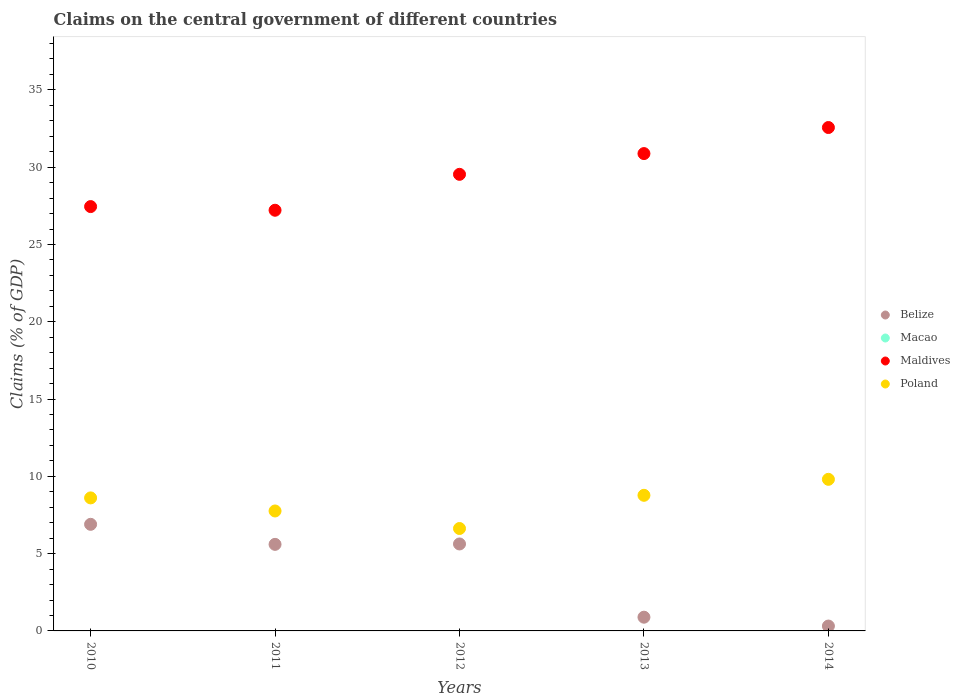How many different coloured dotlines are there?
Give a very brief answer. 3. Is the number of dotlines equal to the number of legend labels?
Keep it short and to the point. No. What is the percentage of GDP claimed on the central government in Belize in 2011?
Keep it short and to the point. 5.6. Across all years, what is the maximum percentage of GDP claimed on the central government in Maldives?
Offer a very short reply. 32.57. Across all years, what is the minimum percentage of GDP claimed on the central government in Poland?
Give a very brief answer. 6.63. What is the total percentage of GDP claimed on the central government in Poland in the graph?
Make the answer very short. 41.57. What is the difference between the percentage of GDP claimed on the central government in Belize in 2012 and that in 2014?
Offer a very short reply. 5.31. What is the difference between the percentage of GDP claimed on the central government in Belize in 2013 and the percentage of GDP claimed on the central government in Macao in 2014?
Your answer should be compact. 0.89. What is the average percentage of GDP claimed on the central government in Maldives per year?
Offer a very short reply. 29.53. In the year 2011, what is the difference between the percentage of GDP claimed on the central government in Belize and percentage of GDP claimed on the central government in Poland?
Make the answer very short. -2.16. In how many years, is the percentage of GDP claimed on the central government in Maldives greater than 5 %?
Your answer should be compact. 5. What is the ratio of the percentage of GDP claimed on the central government in Poland in 2013 to that in 2014?
Give a very brief answer. 0.89. Is the percentage of GDP claimed on the central government in Maldives in 2010 less than that in 2013?
Offer a terse response. Yes. What is the difference between the highest and the second highest percentage of GDP claimed on the central government in Maldives?
Keep it short and to the point. 1.69. What is the difference between the highest and the lowest percentage of GDP claimed on the central government in Belize?
Ensure brevity in your answer.  6.58. Is the sum of the percentage of GDP claimed on the central government in Poland in 2011 and 2014 greater than the maximum percentage of GDP claimed on the central government in Maldives across all years?
Ensure brevity in your answer.  No. Is it the case that in every year, the sum of the percentage of GDP claimed on the central government in Belize and percentage of GDP claimed on the central government in Poland  is greater than the percentage of GDP claimed on the central government in Macao?
Ensure brevity in your answer.  Yes. Does the percentage of GDP claimed on the central government in Belize monotonically increase over the years?
Your answer should be very brief. No. How many dotlines are there?
Your answer should be very brief. 3. How many years are there in the graph?
Provide a succinct answer. 5. How many legend labels are there?
Offer a terse response. 4. What is the title of the graph?
Your response must be concise. Claims on the central government of different countries. What is the label or title of the Y-axis?
Give a very brief answer. Claims (% of GDP). What is the Claims (% of GDP) in Belize in 2010?
Ensure brevity in your answer.  6.9. What is the Claims (% of GDP) in Maldives in 2010?
Give a very brief answer. 27.45. What is the Claims (% of GDP) in Poland in 2010?
Offer a terse response. 8.61. What is the Claims (% of GDP) in Belize in 2011?
Your answer should be very brief. 5.6. What is the Claims (% of GDP) in Macao in 2011?
Offer a terse response. 0. What is the Claims (% of GDP) in Maldives in 2011?
Keep it short and to the point. 27.22. What is the Claims (% of GDP) of Poland in 2011?
Make the answer very short. 7.76. What is the Claims (% of GDP) of Belize in 2012?
Provide a short and direct response. 5.63. What is the Claims (% of GDP) in Macao in 2012?
Offer a very short reply. 0. What is the Claims (% of GDP) of Maldives in 2012?
Make the answer very short. 29.54. What is the Claims (% of GDP) in Poland in 2012?
Ensure brevity in your answer.  6.63. What is the Claims (% of GDP) of Belize in 2013?
Provide a short and direct response. 0.89. What is the Claims (% of GDP) in Maldives in 2013?
Your response must be concise. 30.88. What is the Claims (% of GDP) in Poland in 2013?
Your response must be concise. 8.77. What is the Claims (% of GDP) of Belize in 2014?
Your answer should be compact. 0.32. What is the Claims (% of GDP) of Macao in 2014?
Your response must be concise. 0. What is the Claims (% of GDP) of Maldives in 2014?
Your response must be concise. 32.57. What is the Claims (% of GDP) of Poland in 2014?
Keep it short and to the point. 9.81. Across all years, what is the maximum Claims (% of GDP) of Belize?
Offer a terse response. 6.9. Across all years, what is the maximum Claims (% of GDP) of Maldives?
Ensure brevity in your answer.  32.57. Across all years, what is the maximum Claims (% of GDP) in Poland?
Offer a terse response. 9.81. Across all years, what is the minimum Claims (% of GDP) in Belize?
Offer a terse response. 0.32. Across all years, what is the minimum Claims (% of GDP) of Maldives?
Offer a very short reply. 27.22. Across all years, what is the minimum Claims (% of GDP) of Poland?
Make the answer very short. 6.63. What is the total Claims (% of GDP) of Belize in the graph?
Make the answer very short. 19.33. What is the total Claims (% of GDP) of Maldives in the graph?
Make the answer very short. 147.65. What is the total Claims (% of GDP) in Poland in the graph?
Your response must be concise. 41.57. What is the difference between the Claims (% of GDP) of Belize in 2010 and that in 2011?
Offer a very short reply. 1.3. What is the difference between the Claims (% of GDP) of Maldives in 2010 and that in 2011?
Your response must be concise. 0.24. What is the difference between the Claims (% of GDP) of Poland in 2010 and that in 2011?
Your response must be concise. 0.85. What is the difference between the Claims (% of GDP) in Belize in 2010 and that in 2012?
Keep it short and to the point. 1.27. What is the difference between the Claims (% of GDP) in Maldives in 2010 and that in 2012?
Your answer should be compact. -2.09. What is the difference between the Claims (% of GDP) in Poland in 2010 and that in 2012?
Keep it short and to the point. 1.98. What is the difference between the Claims (% of GDP) of Belize in 2010 and that in 2013?
Give a very brief answer. 6.01. What is the difference between the Claims (% of GDP) in Maldives in 2010 and that in 2013?
Your answer should be very brief. -3.43. What is the difference between the Claims (% of GDP) in Poland in 2010 and that in 2013?
Ensure brevity in your answer.  -0.17. What is the difference between the Claims (% of GDP) of Belize in 2010 and that in 2014?
Provide a short and direct response. 6.58. What is the difference between the Claims (% of GDP) of Maldives in 2010 and that in 2014?
Provide a short and direct response. -5.12. What is the difference between the Claims (% of GDP) in Poland in 2010 and that in 2014?
Give a very brief answer. -1.2. What is the difference between the Claims (% of GDP) of Belize in 2011 and that in 2012?
Offer a very short reply. -0.03. What is the difference between the Claims (% of GDP) in Maldives in 2011 and that in 2012?
Offer a very short reply. -2.32. What is the difference between the Claims (% of GDP) in Poland in 2011 and that in 2012?
Your response must be concise. 1.13. What is the difference between the Claims (% of GDP) of Belize in 2011 and that in 2013?
Give a very brief answer. 4.71. What is the difference between the Claims (% of GDP) in Maldives in 2011 and that in 2013?
Keep it short and to the point. -3.67. What is the difference between the Claims (% of GDP) in Poland in 2011 and that in 2013?
Your answer should be compact. -1.01. What is the difference between the Claims (% of GDP) of Belize in 2011 and that in 2014?
Ensure brevity in your answer.  5.28. What is the difference between the Claims (% of GDP) in Maldives in 2011 and that in 2014?
Give a very brief answer. -5.35. What is the difference between the Claims (% of GDP) in Poland in 2011 and that in 2014?
Your answer should be very brief. -2.05. What is the difference between the Claims (% of GDP) of Belize in 2012 and that in 2013?
Give a very brief answer. 4.74. What is the difference between the Claims (% of GDP) in Maldives in 2012 and that in 2013?
Your answer should be compact. -1.34. What is the difference between the Claims (% of GDP) of Poland in 2012 and that in 2013?
Provide a short and direct response. -2.15. What is the difference between the Claims (% of GDP) of Belize in 2012 and that in 2014?
Ensure brevity in your answer.  5.31. What is the difference between the Claims (% of GDP) of Maldives in 2012 and that in 2014?
Offer a terse response. -3.03. What is the difference between the Claims (% of GDP) in Poland in 2012 and that in 2014?
Offer a terse response. -3.18. What is the difference between the Claims (% of GDP) of Belize in 2013 and that in 2014?
Provide a short and direct response. 0.57. What is the difference between the Claims (% of GDP) of Maldives in 2013 and that in 2014?
Provide a short and direct response. -1.69. What is the difference between the Claims (% of GDP) of Poland in 2013 and that in 2014?
Your response must be concise. -1.03. What is the difference between the Claims (% of GDP) of Belize in 2010 and the Claims (% of GDP) of Maldives in 2011?
Ensure brevity in your answer.  -20.32. What is the difference between the Claims (% of GDP) of Belize in 2010 and the Claims (% of GDP) of Poland in 2011?
Make the answer very short. -0.86. What is the difference between the Claims (% of GDP) in Maldives in 2010 and the Claims (% of GDP) in Poland in 2011?
Your answer should be very brief. 19.69. What is the difference between the Claims (% of GDP) of Belize in 2010 and the Claims (% of GDP) of Maldives in 2012?
Keep it short and to the point. -22.64. What is the difference between the Claims (% of GDP) in Belize in 2010 and the Claims (% of GDP) in Poland in 2012?
Provide a succinct answer. 0.27. What is the difference between the Claims (% of GDP) of Maldives in 2010 and the Claims (% of GDP) of Poland in 2012?
Offer a very short reply. 20.83. What is the difference between the Claims (% of GDP) of Belize in 2010 and the Claims (% of GDP) of Maldives in 2013?
Make the answer very short. -23.98. What is the difference between the Claims (% of GDP) of Belize in 2010 and the Claims (% of GDP) of Poland in 2013?
Give a very brief answer. -1.88. What is the difference between the Claims (% of GDP) in Maldives in 2010 and the Claims (% of GDP) in Poland in 2013?
Offer a very short reply. 18.68. What is the difference between the Claims (% of GDP) in Belize in 2010 and the Claims (% of GDP) in Maldives in 2014?
Your response must be concise. -25.67. What is the difference between the Claims (% of GDP) in Belize in 2010 and the Claims (% of GDP) in Poland in 2014?
Provide a succinct answer. -2.91. What is the difference between the Claims (% of GDP) in Maldives in 2010 and the Claims (% of GDP) in Poland in 2014?
Give a very brief answer. 17.64. What is the difference between the Claims (% of GDP) in Belize in 2011 and the Claims (% of GDP) in Maldives in 2012?
Your response must be concise. -23.94. What is the difference between the Claims (% of GDP) of Belize in 2011 and the Claims (% of GDP) of Poland in 2012?
Ensure brevity in your answer.  -1.03. What is the difference between the Claims (% of GDP) of Maldives in 2011 and the Claims (% of GDP) of Poland in 2012?
Keep it short and to the point. 20.59. What is the difference between the Claims (% of GDP) of Belize in 2011 and the Claims (% of GDP) of Maldives in 2013?
Offer a very short reply. -25.28. What is the difference between the Claims (% of GDP) of Belize in 2011 and the Claims (% of GDP) of Poland in 2013?
Give a very brief answer. -3.17. What is the difference between the Claims (% of GDP) in Maldives in 2011 and the Claims (% of GDP) in Poland in 2013?
Your answer should be compact. 18.44. What is the difference between the Claims (% of GDP) in Belize in 2011 and the Claims (% of GDP) in Maldives in 2014?
Keep it short and to the point. -26.97. What is the difference between the Claims (% of GDP) in Belize in 2011 and the Claims (% of GDP) in Poland in 2014?
Keep it short and to the point. -4.21. What is the difference between the Claims (% of GDP) of Maldives in 2011 and the Claims (% of GDP) of Poland in 2014?
Your answer should be very brief. 17.41. What is the difference between the Claims (% of GDP) of Belize in 2012 and the Claims (% of GDP) of Maldives in 2013?
Provide a short and direct response. -25.25. What is the difference between the Claims (% of GDP) of Belize in 2012 and the Claims (% of GDP) of Poland in 2013?
Your answer should be very brief. -3.15. What is the difference between the Claims (% of GDP) in Maldives in 2012 and the Claims (% of GDP) in Poland in 2013?
Ensure brevity in your answer.  20.77. What is the difference between the Claims (% of GDP) of Belize in 2012 and the Claims (% of GDP) of Maldives in 2014?
Give a very brief answer. -26.94. What is the difference between the Claims (% of GDP) of Belize in 2012 and the Claims (% of GDP) of Poland in 2014?
Offer a very short reply. -4.18. What is the difference between the Claims (% of GDP) of Maldives in 2012 and the Claims (% of GDP) of Poland in 2014?
Keep it short and to the point. 19.73. What is the difference between the Claims (% of GDP) in Belize in 2013 and the Claims (% of GDP) in Maldives in 2014?
Your answer should be very brief. -31.68. What is the difference between the Claims (% of GDP) in Belize in 2013 and the Claims (% of GDP) in Poland in 2014?
Your response must be concise. -8.92. What is the difference between the Claims (% of GDP) in Maldives in 2013 and the Claims (% of GDP) in Poland in 2014?
Your answer should be compact. 21.07. What is the average Claims (% of GDP) of Belize per year?
Your answer should be very brief. 3.87. What is the average Claims (% of GDP) of Macao per year?
Offer a terse response. 0. What is the average Claims (% of GDP) of Maldives per year?
Offer a terse response. 29.53. What is the average Claims (% of GDP) of Poland per year?
Offer a terse response. 8.31. In the year 2010, what is the difference between the Claims (% of GDP) in Belize and Claims (% of GDP) in Maldives?
Ensure brevity in your answer.  -20.56. In the year 2010, what is the difference between the Claims (% of GDP) in Belize and Claims (% of GDP) in Poland?
Provide a succinct answer. -1.71. In the year 2010, what is the difference between the Claims (% of GDP) of Maldives and Claims (% of GDP) of Poland?
Offer a terse response. 18.85. In the year 2011, what is the difference between the Claims (% of GDP) in Belize and Claims (% of GDP) in Maldives?
Your answer should be very brief. -21.62. In the year 2011, what is the difference between the Claims (% of GDP) in Belize and Claims (% of GDP) in Poland?
Offer a terse response. -2.16. In the year 2011, what is the difference between the Claims (% of GDP) of Maldives and Claims (% of GDP) of Poland?
Offer a terse response. 19.46. In the year 2012, what is the difference between the Claims (% of GDP) in Belize and Claims (% of GDP) in Maldives?
Provide a succinct answer. -23.91. In the year 2012, what is the difference between the Claims (% of GDP) of Belize and Claims (% of GDP) of Poland?
Provide a short and direct response. -1. In the year 2012, what is the difference between the Claims (% of GDP) in Maldives and Claims (% of GDP) in Poland?
Your response must be concise. 22.91. In the year 2013, what is the difference between the Claims (% of GDP) in Belize and Claims (% of GDP) in Maldives?
Keep it short and to the point. -29.99. In the year 2013, what is the difference between the Claims (% of GDP) in Belize and Claims (% of GDP) in Poland?
Make the answer very short. -7.89. In the year 2013, what is the difference between the Claims (% of GDP) in Maldives and Claims (% of GDP) in Poland?
Make the answer very short. 22.11. In the year 2014, what is the difference between the Claims (% of GDP) in Belize and Claims (% of GDP) in Maldives?
Make the answer very short. -32.25. In the year 2014, what is the difference between the Claims (% of GDP) of Belize and Claims (% of GDP) of Poland?
Offer a terse response. -9.49. In the year 2014, what is the difference between the Claims (% of GDP) of Maldives and Claims (% of GDP) of Poland?
Your response must be concise. 22.76. What is the ratio of the Claims (% of GDP) of Belize in 2010 to that in 2011?
Keep it short and to the point. 1.23. What is the ratio of the Claims (% of GDP) in Maldives in 2010 to that in 2011?
Provide a short and direct response. 1.01. What is the ratio of the Claims (% of GDP) of Poland in 2010 to that in 2011?
Offer a very short reply. 1.11. What is the ratio of the Claims (% of GDP) in Belize in 2010 to that in 2012?
Offer a terse response. 1.23. What is the ratio of the Claims (% of GDP) in Maldives in 2010 to that in 2012?
Make the answer very short. 0.93. What is the ratio of the Claims (% of GDP) of Poland in 2010 to that in 2012?
Provide a short and direct response. 1.3. What is the ratio of the Claims (% of GDP) in Belize in 2010 to that in 2013?
Make the answer very short. 7.77. What is the ratio of the Claims (% of GDP) in Maldives in 2010 to that in 2013?
Make the answer very short. 0.89. What is the ratio of the Claims (% of GDP) of Poland in 2010 to that in 2013?
Give a very brief answer. 0.98. What is the ratio of the Claims (% of GDP) of Belize in 2010 to that in 2014?
Offer a terse response. 21.88. What is the ratio of the Claims (% of GDP) of Maldives in 2010 to that in 2014?
Make the answer very short. 0.84. What is the ratio of the Claims (% of GDP) of Poland in 2010 to that in 2014?
Offer a very short reply. 0.88. What is the ratio of the Claims (% of GDP) in Maldives in 2011 to that in 2012?
Offer a very short reply. 0.92. What is the ratio of the Claims (% of GDP) of Poland in 2011 to that in 2012?
Provide a succinct answer. 1.17. What is the ratio of the Claims (% of GDP) in Belize in 2011 to that in 2013?
Offer a terse response. 6.31. What is the ratio of the Claims (% of GDP) in Maldives in 2011 to that in 2013?
Make the answer very short. 0.88. What is the ratio of the Claims (% of GDP) of Poland in 2011 to that in 2013?
Ensure brevity in your answer.  0.88. What is the ratio of the Claims (% of GDP) in Belize in 2011 to that in 2014?
Ensure brevity in your answer.  17.77. What is the ratio of the Claims (% of GDP) of Maldives in 2011 to that in 2014?
Your answer should be compact. 0.84. What is the ratio of the Claims (% of GDP) in Poland in 2011 to that in 2014?
Give a very brief answer. 0.79. What is the ratio of the Claims (% of GDP) in Belize in 2012 to that in 2013?
Your answer should be compact. 6.34. What is the ratio of the Claims (% of GDP) in Maldives in 2012 to that in 2013?
Ensure brevity in your answer.  0.96. What is the ratio of the Claims (% of GDP) in Poland in 2012 to that in 2013?
Ensure brevity in your answer.  0.76. What is the ratio of the Claims (% of GDP) in Belize in 2012 to that in 2014?
Ensure brevity in your answer.  17.85. What is the ratio of the Claims (% of GDP) in Maldives in 2012 to that in 2014?
Keep it short and to the point. 0.91. What is the ratio of the Claims (% of GDP) of Poland in 2012 to that in 2014?
Provide a succinct answer. 0.68. What is the ratio of the Claims (% of GDP) in Belize in 2013 to that in 2014?
Provide a succinct answer. 2.82. What is the ratio of the Claims (% of GDP) of Maldives in 2013 to that in 2014?
Offer a terse response. 0.95. What is the ratio of the Claims (% of GDP) of Poland in 2013 to that in 2014?
Your answer should be very brief. 0.89. What is the difference between the highest and the second highest Claims (% of GDP) of Belize?
Make the answer very short. 1.27. What is the difference between the highest and the second highest Claims (% of GDP) of Maldives?
Your answer should be compact. 1.69. What is the difference between the highest and the second highest Claims (% of GDP) of Poland?
Ensure brevity in your answer.  1.03. What is the difference between the highest and the lowest Claims (% of GDP) in Belize?
Offer a terse response. 6.58. What is the difference between the highest and the lowest Claims (% of GDP) in Maldives?
Your answer should be very brief. 5.35. What is the difference between the highest and the lowest Claims (% of GDP) in Poland?
Keep it short and to the point. 3.18. 